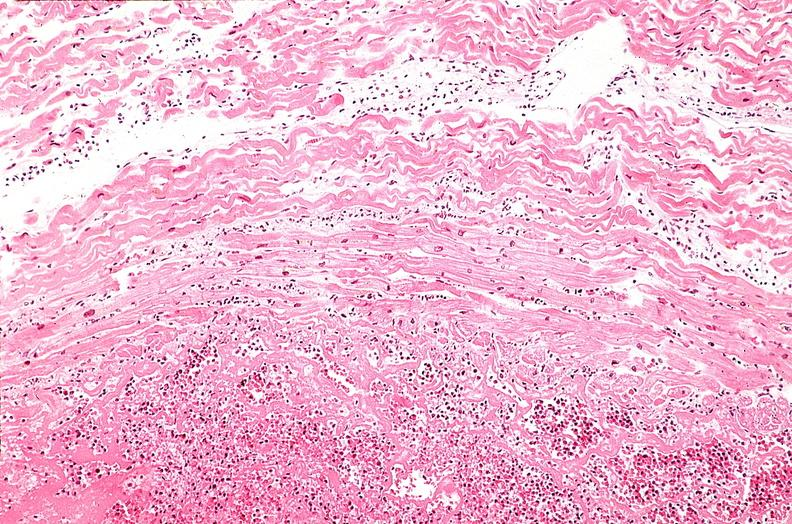s cardiovascular present?
Answer the question using a single word or phrase. Yes 